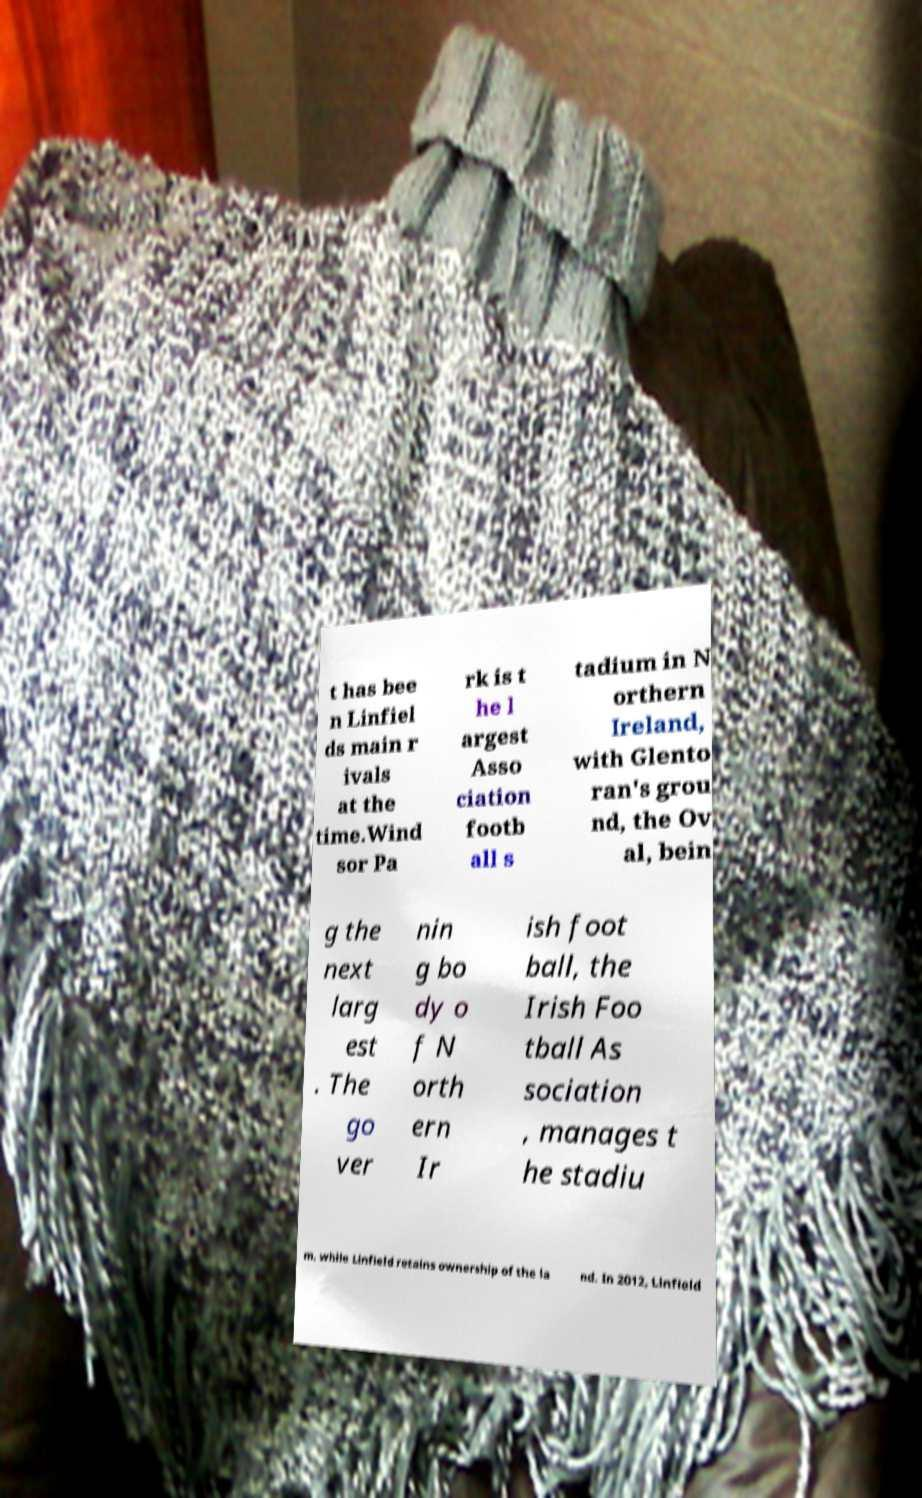Please identify and transcribe the text found in this image. t has bee n Linfiel ds main r ivals at the time.Wind sor Pa rk is t he l argest Asso ciation footb all s tadium in N orthern Ireland, with Glento ran's grou nd, the Ov al, bein g the next larg est . The go ver nin g bo dy o f N orth ern Ir ish foot ball, the Irish Foo tball As sociation , manages t he stadiu m, while Linfield retains ownership of the la nd. In 2012, Linfield 